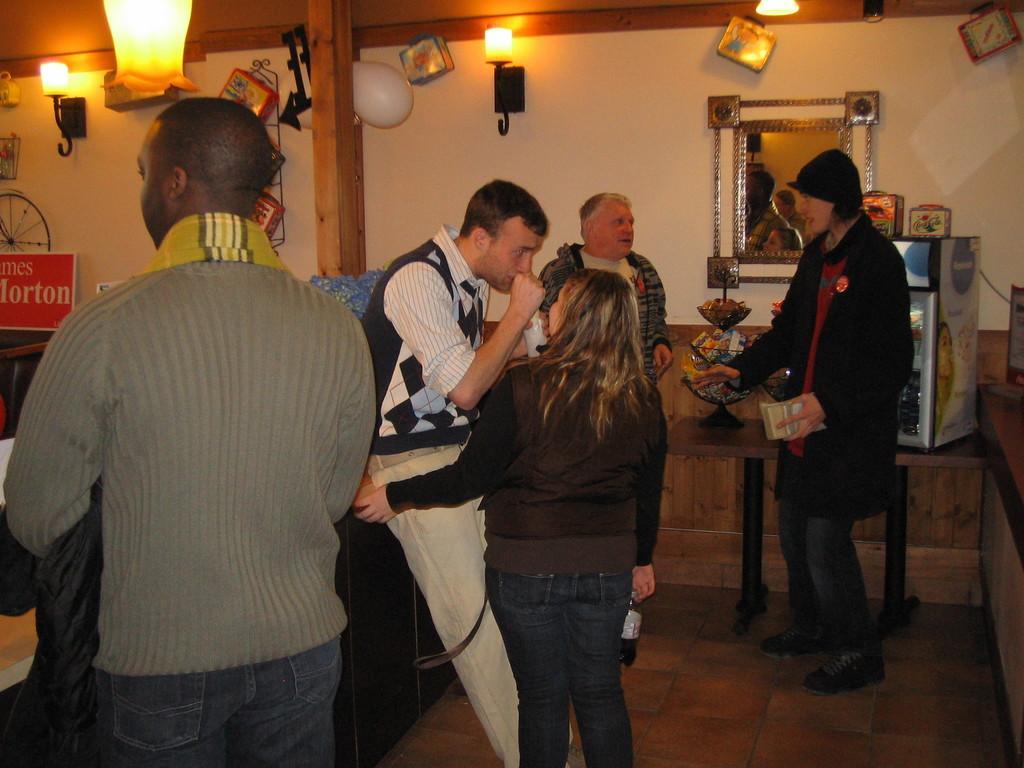Could you give a brief overview of what you see in this image? In this picture I can see a few people standing and I can see a man holding a can in his hand and a woman holding a bottle and another woman holding something in her hand and I can see small refrigerator on the table and looks like a mirror on the wall and I can see few lights and balloons and I can see board with some text on the left side and I can see another table on the right side and I can see small stand on the table. 